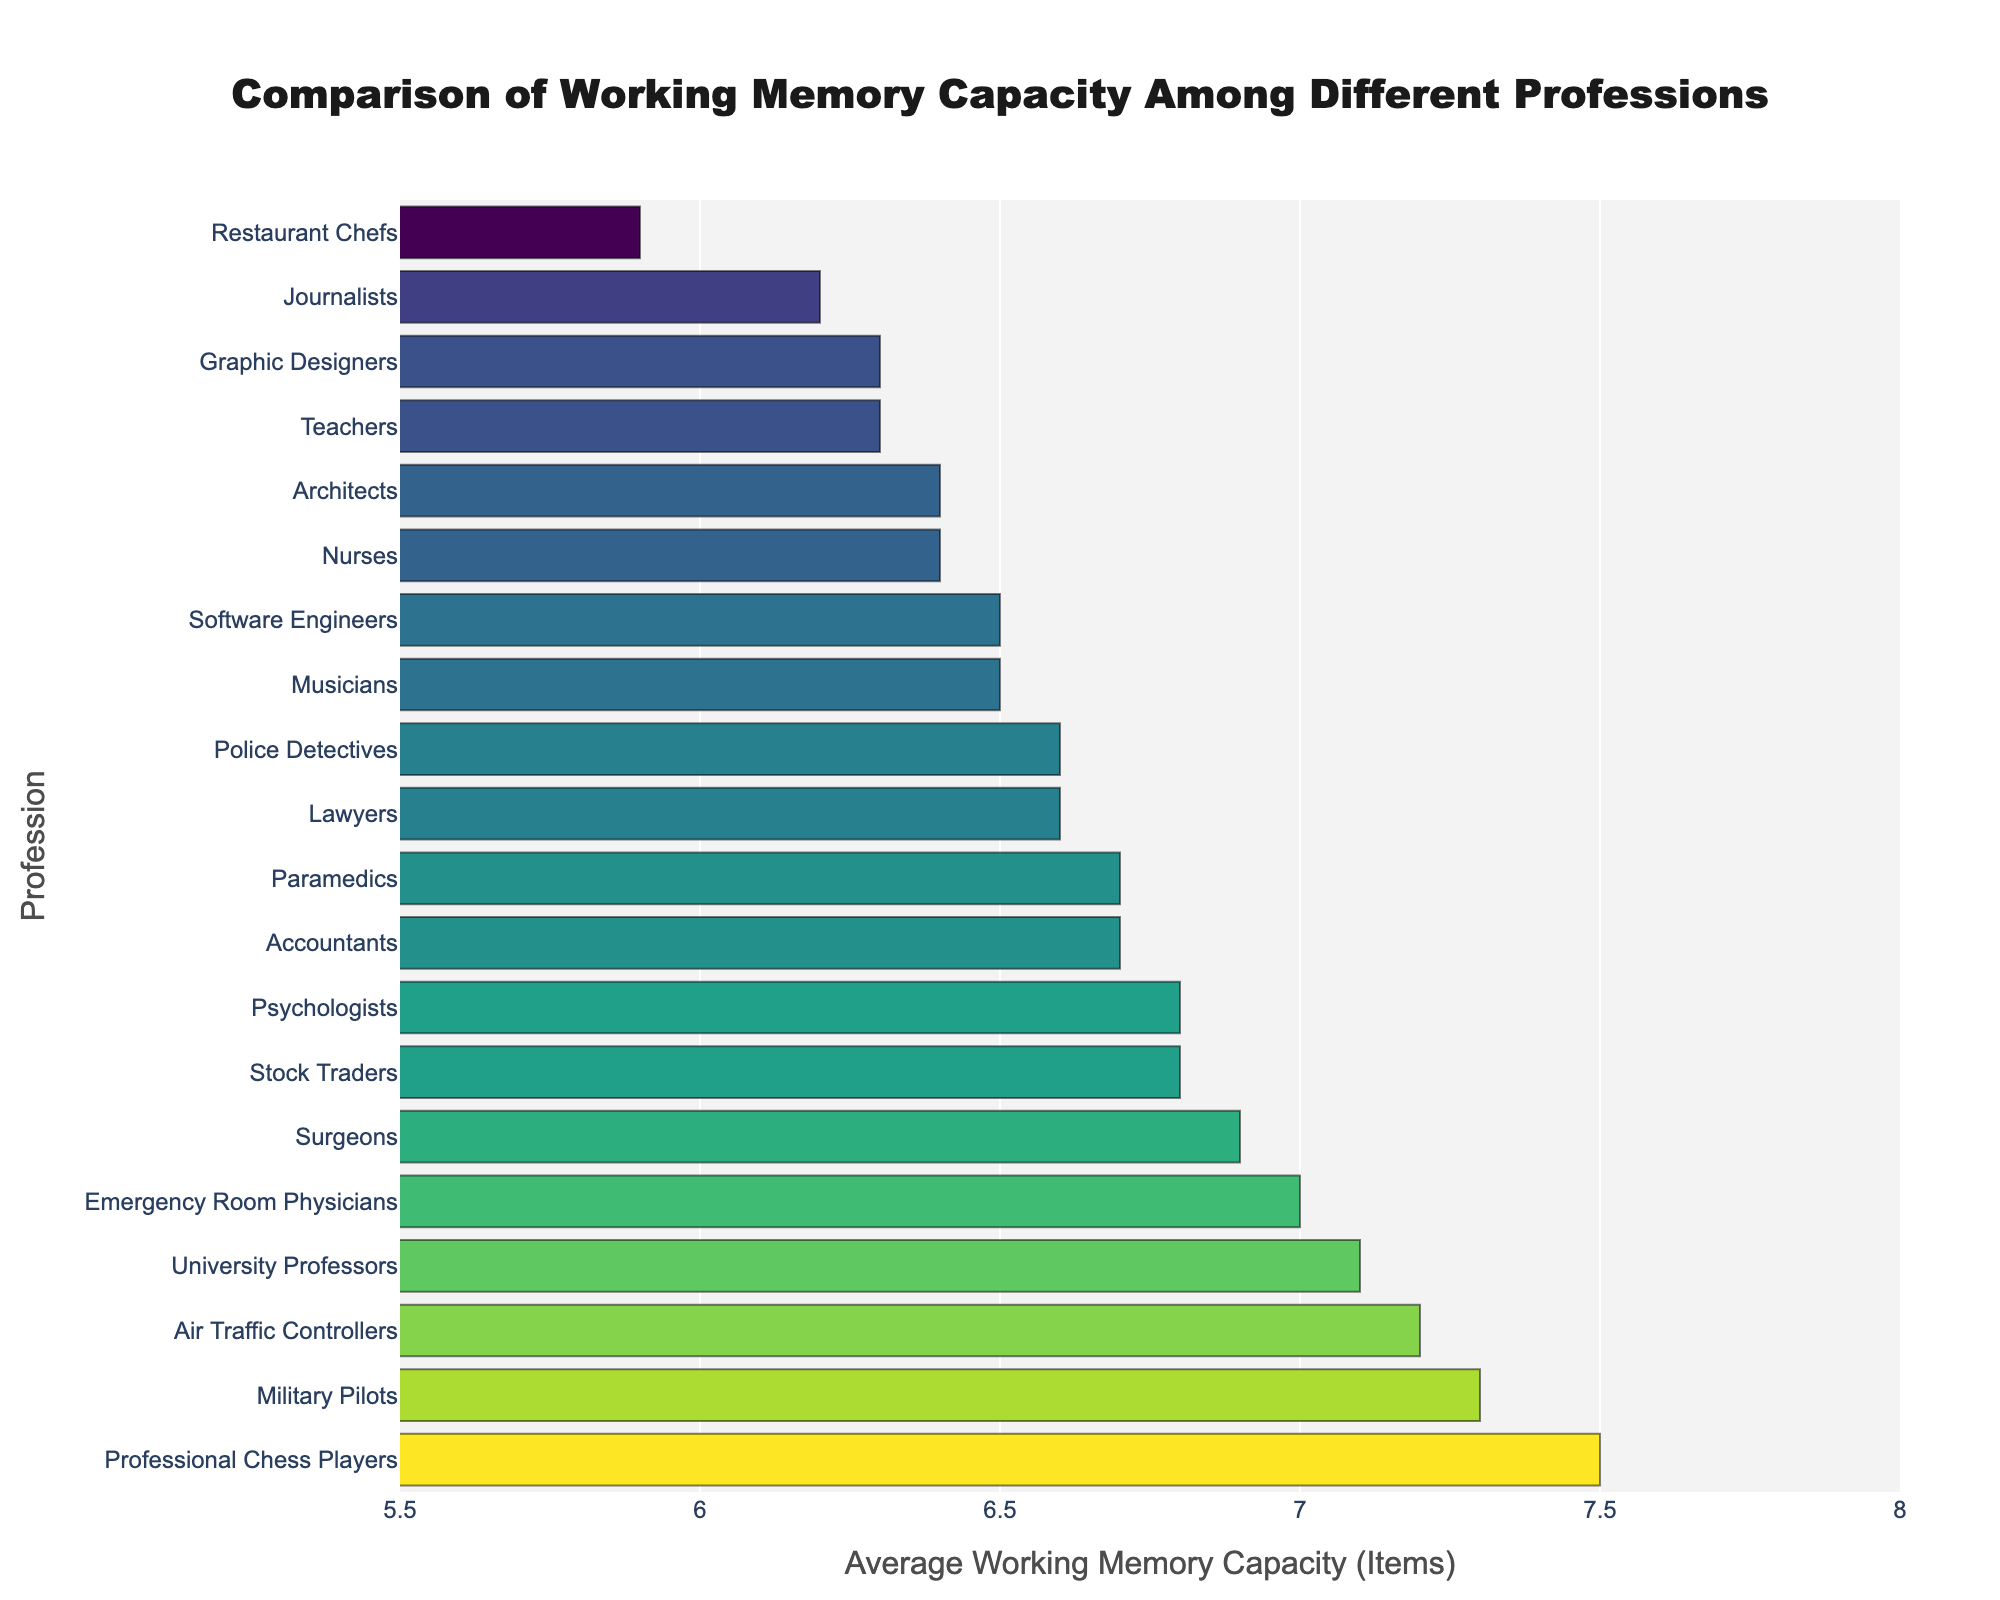Which profession has the highest average working memory capacity? The bar for Professional Chess Players is the longest, reaching 7.5 items, indicating the highest average working memory capacity among the listed professions.
Answer: Professional Chess Players Which profession has the lowest average working memory capacity? The bar for Restaurant Chefs is the shortest, reaching 5.9 items, indicating the lowest average working memory capacity among the listed professions.
Answer: Restaurant Chefs What is the difference in average working memory capacity between Air Traffic Controllers and Restaurant Chefs? The average working memory capacity for Air Traffic Controllers is 7.2 items, while it is 5.9 items for Restaurant Chefs. The difference is 7.2 - 5.9.
Answer: 1.3 How many professions have an average working memory capacity of 6.5 items or greater? Identify and count the number of bars with values 6.5 or greater: Psychologists, Air Traffic Controllers, Software Engineers, Emergency Room Physicians, Professional Chess Players, Accountants, Nurses, Lawyers, Military Pilots, Surgeons, Stock Traders, University Professors, Police Detectives, Paramedics, Musicians, Teachers, and Architects.
Answer: 16 professions Identify one profession with an average working memory capacity of less than 6.0 items. Check for the shortest bars and find the respective profession below 6.0 items; Restaurant Chefs is one such example with an average working memory capacity of 5.9 items.
Answer: Restaurant Chefs Which profession has a slightly higher average working memory capacity: Accountants or Nurses? Compare the bar lengths for Accountants and Nurses. Accountants have an average working memory capacity of 6.7 items, while Nurses have 6.4 items.
Answer: Accountants Are there more professions with an average working memory capacity above 7.0 items or below 6.5 items? Count professions above 7.0 items (Air Traffic Controllers, Emergency Room Physicians, Professional Chess Players, Military Pilots, University Professors) which are 5, and those below 6.5 items (Teachers, Accountants, Nurses, Lawyers, Restaurant Chefs, Journalists, Graphic Designers, Paramedics) which are 8.
Answer: Below 6.5 items What is the average working memory capacity for the top three professions? The top three professions based on average working memory capacity are Professional Chess Players (7.5), Military Pilots (7.3), and Air Traffic Controllers (7.2). The average is (7.5 + 7.3 + 7.2) / 3.
Answer: 7.33 How much higher is the average working memory capacity of University Professors compared to Teachers? University Professors have an average working memory capacity of 7.1 items, and Teachers have 6.3 items. The difference is 7.1 - 6.3.
Answer: 0.8 What is the color of the bar representing journalists? The bar colors follow a Viridis colorscale, with bars getting darker as values increase. The bar for Journalists, at 6.2 items, is at the lighter end of this scale.
Answer: Lighter shade 